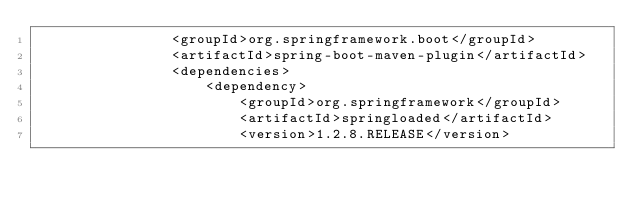<code> <loc_0><loc_0><loc_500><loc_500><_XML_>				<groupId>org.springframework.boot</groupId>
				<artifactId>spring-boot-maven-plugin</artifactId>
				<dependencies>
					<dependency>
						<groupId>org.springframework</groupId>
						<artifactId>springloaded</artifactId>
						<version>1.2.8.RELEASE</version></code> 